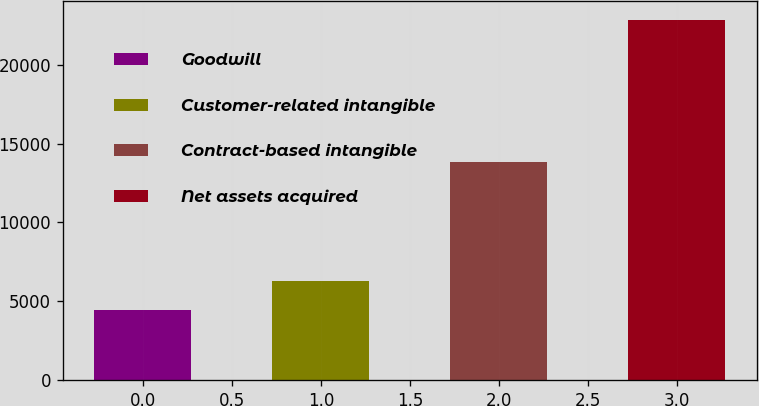Convert chart. <chart><loc_0><loc_0><loc_500><loc_500><bar_chart><fcel>Goodwill<fcel>Customer-related intangible<fcel>Contract-based intangible<fcel>Net assets acquired<nl><fcel>4445<fcel>6288.4<fcel>13858<fcel>22879<nl></chart> 